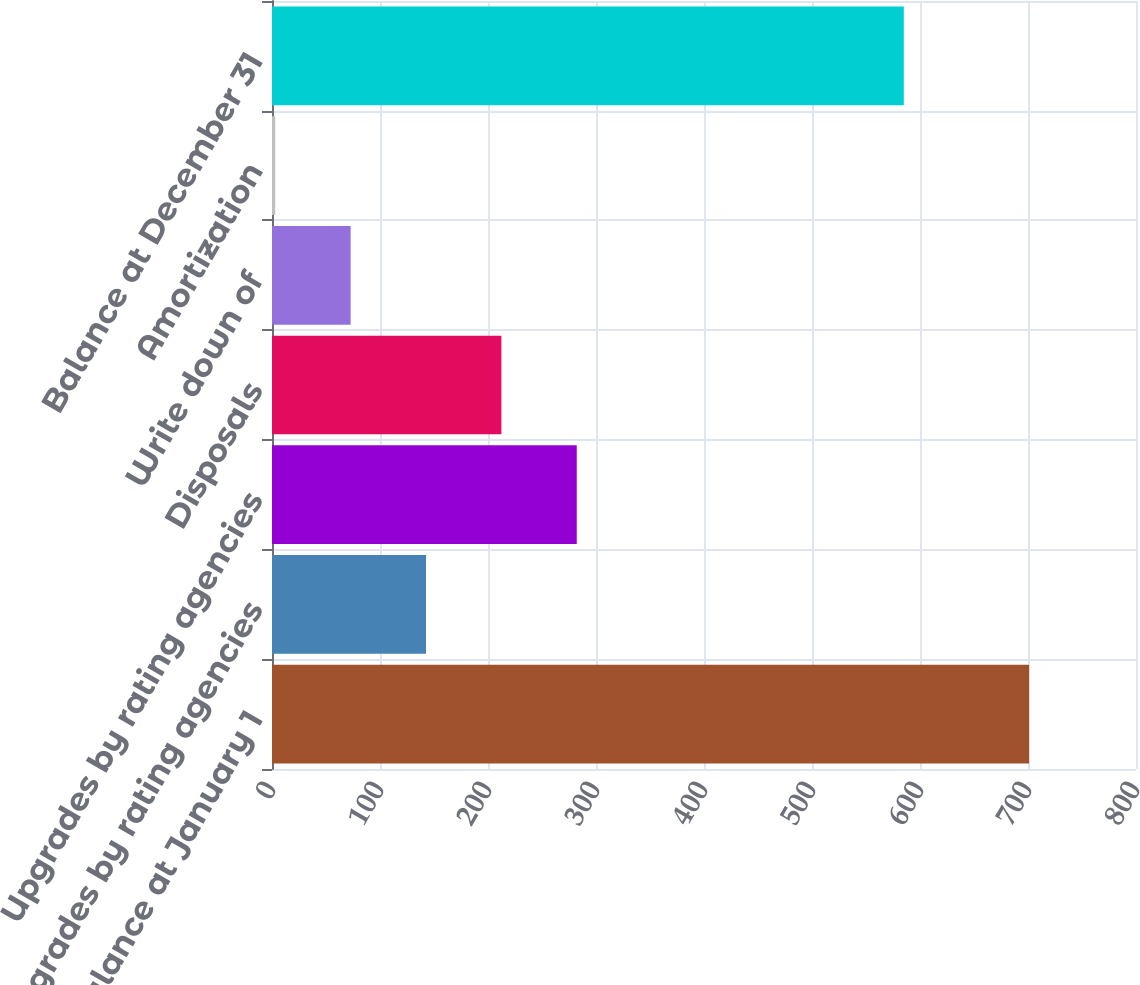Convert chart to OTSL. <chart><loc_0><loc_0><loc_500><loc_500><bar_chart><fcel>Balance at January 1<fcel>Downgrades by rating agencies<fcel>Upgrades by rating agencies<fcel>Disposals<fcel>Write down of<fcel>Amortization<fcel>Balance at December 31<nl><fcel>701<fcel>142.6<fcel>282.2<fcel>212.4<fcel>72.8<fcel>3<fcel>585<nl></chart> 